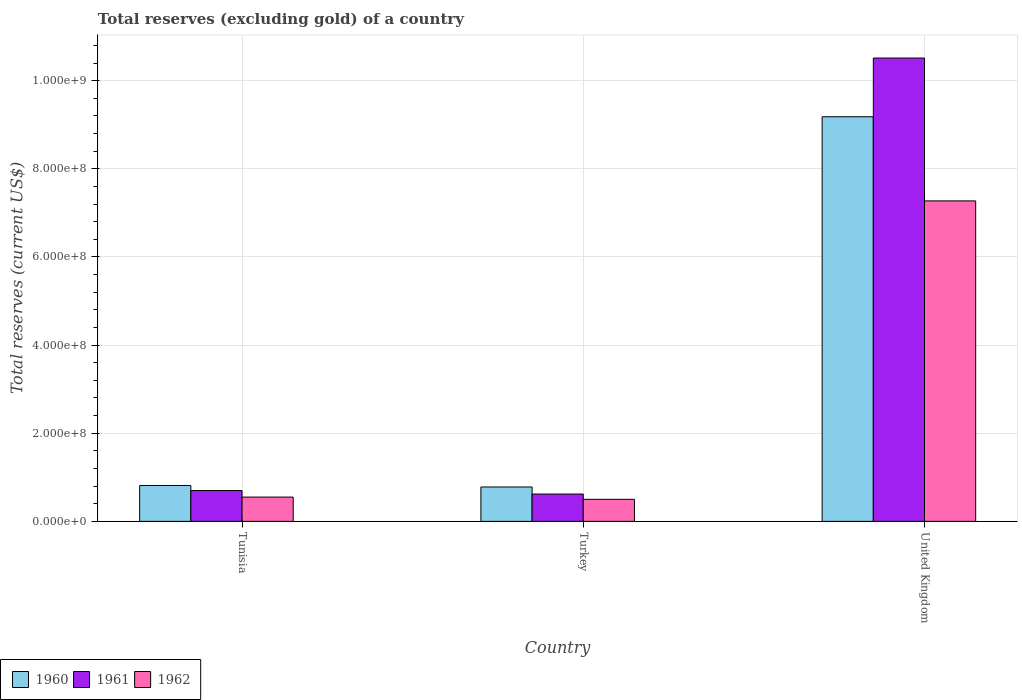How many different coloured bars are there?
Provide a short and direct response. 3. How many groups of bars are there?
Provide a short and direct response. 3. Are the number of bars on each tick of the X-axis equal?
Offer a terse response. Yes. What is the label of the 2nd group of bars from the left?
Provide a short and direct response. Turkey. What is the total reserves (excluding gold) in 1960 in Turkey?
Keep it short and to the point. 7.80e+07. Across all countries, what is the maximum total reserves (excluding gold) in 1962?
Provide a succinct answer. 7.27e+08. Across all countries, what is the minimum total reserves (excluding gold) in 1960?
Provide a short and direct response. 7.80e+07. In which country was the total reserves (excluding gold) in 1960 maximum?
Provide a short and direct response. United Kingdom. In which country was the total reserves (excluding gold) in 1961 minimum?
Your answer should be compact. Turkey. What is the total total reserves (excluding gold) in 1961 in the graph?
Offer a terse response. 1.18e+09. What is the difference between the total reserves (excluding gold) in 1962 in Tunisia and that in Turkey?
Offer a terse response. 5.10e+06. What is the difference between the total reserves (excluding gold) in 1962 in Tunisia and the total reserves (excluding gold) in 1961 in Turkey?
Your response must be concise. -6.90e+06. What is the average total reserves (excluding gold) in 1962 per country?
Give a very brief answer. 2.77e+08. What is the difference between the total reserves (excluding gold) of/in 1962 and total reserves (excluding gold) of/in 1960 in Tunisia?
Your answer should be compact. -2.63e+07. What is the ratio of the total reserves (excluding gold) in 1960 in Turkey to that in United Kingdom?
Keep it short and to the point. 0.08. Is the total reserves (excluding gold) in 1962 in Tunisia less than that in Turkey?
Your response must be concise. No. What is the difference between the highest and the second highest total reserves (excluding gold) in 1960?
Provide a succinct answer. 8.40e+08. What is the difference between the highest and the lowest total reserves (excluding gold) in 1960?
Your answer should be very brief. 8.40e+08. Is the sum of the total reserves (excluding gold) in 1960 in Tunisia and Turkey greater than the maximum total reserves (excluding gold) in 1961 across all countries?
Your response must be concise. No. What does the 3rd bar from the right in United Kingdom represents?
Provide a short and direct response. 1960. Is it the case that in every country, the sum of the total reserves (excluding gold) in 1960 and total reserves (excluding gold) in 1961 is greater than the total reserves (excluding gold) in 1962?
Ensure brevity in your answer.  Yes. Are all the bars in the graph horizontal?
Ensure brevity in your answer.  No. How many countries are there in the graph?
Your response must be concise. 3. Does the graph contain any zero values?
Keep it short and to the point. No. How are the legend labels stacked?
Ensure brevity in your answer.  Horizontal. What is the title of the graph?
Offer a terse response. Total reserves (excluding gold) of a country. What is the label or title of the Y-axis?
Offer a terse response. Total reserves (current US$). What is the Total reserves (current US$) of 1960 in Tunisia?
Your answer should be compact. 8.14e+07. What is the Total reserves (current US$) in 1961 in Tunisia?
Your answer should be compact. 6.99e+07. What is the Total reserves (current US$) of 1962 in Tunisia?
Provide a succinct answer. 5.51e+07. What is the Total reserves (current US$) of 1960 in Turkey?
Your answer should be compact. 7.80e+07. What is the Total reserves (current US$) in 1961 in Turkey?
Offer a terse response. 6.20e+07. What is the Total reserves (current US$) of 1960 in United Kingdom?
Keep it short and to the point. 9.18e+08. What is the Total reserves (current US$) in 1961 in United Kingdom?
Provide a short and direct response. 1.05e+09. What is the Total reserves (current US$) of 1962 in United Kingdom?
Your answer should be compact. 7.27e+08. Across all countries, what is the maximum Total reserves (current US$) in 1960?
Provide a succinct answer. 9.18e+08. Across all countries, what is the maximum Total reserves (current US$) in 1961?
Provide a short and direct response. 1.05e+09. Across all countries, what is the maximum Total reserves (current US$) of 1962?
Keep it short and to the point. 7.27e+08. Across all countries, what is the minimum Total reserves (current US$) of 1960?
Keep it short and to the point. 7.80e+07. Across all countries, what is the minimum Total reserves (current US$) in 1961?
Give a very brief answer. 6.20e+07. Across all countries, what is the minimum Total reserves (current US$) of 1962?
Make the answer very short. 5.00e+07. What is the total Total reserves (current US$) of 1960 in the graph?
Give a very brief answer. 1.08e+09. What is the total Total reserves (current US$) in 1961 in the graph?
Offer a terse response. 1.18e+09. What is the total Total reserves (current US$) in 1962 in the graph?
Your answer should be very brief. 8.32e+08. What is the difference between the Total reserves (current US$) in 1960 in Tunisia and that in Turkey?
Provide a succinct answer. 3.40e+06. What is the difference between the Total reserves (current US$) in 1961 in Tunisia and that in Turkey?
Your answer should be very brief. 7.90e+06. What is the difference between the Total reserves (current US$) in 1962 in Tunisia and that in Turkey?
Provide a short and direct response. 5.10e+06. What is the difference between the Total reserves (current US$) in 1960 in Tunisia and that in United Kingdom?
Offer a very short reply. -8.37e+08. What is the difference between the Total reserves (current US$) in 1961 in Tunisia and that in United Kingdom?
Provide a short and direct response. -9.81e+08. What is the difference between the Total reserves (current US$) in 1962 in Tunisia and that in United Kingdom?
Your answer should be very brief. -6.72e+08. What is the difference between the Total reserves (current US$) in 1960 in Turkey and that in United Kingdom?
Provide a short and direct response. -8.40e+08. What is the difference between the Total reserves (current US$) of 1961 in Turkey and that in United Kingdom?
Your response must be concise. -9.89e+08. What is the difference between the Total reserves (current US$) in 1962 in Turkey and that in United Kingdom?
Give a very brief answer. -6.77e+08. What is the difference between the Total reserves (current US$) in 1960 in Tunisia and the Total reserves (current US$) in 1961 in Turkey?
Your answer should be very brief. 1.94e+07. What is the difference between the Total reserves (current US$) of 1960 in Tunisia and the Total reserves (current US$) of 1962 in Turkey?
Make the answer very short. 3.14e+07. What is the difference between the Total reserves (current US$) of 1961 in Tunisia and the Total reserves (current US$) of 1962 in Turkey?
Provide a succinct answer. 1.99e+07. What is the difference between the Total reserves (current US$) in 1960 in Tunisia and the Total reserves (current US$) in 1961 in United Kingdom?
Give a very brief answer. -9.70e+08. What is the difference between the Total reserves (current US$) of 1960 in Tunisia and the Total reserves (current US$) of 1962 in United Kingdom?
Your answer should be very brief. -6.46e+08. What is the difference between the Total reserves (current US$) in 1961 in Tunisia and the Total reserves (current US$) in 1962 in United Kingdom?
Your response must be concise. -6.57e+08. What is the difference between the Total reserves (current US$) in 1960 in Turkey and the Total reserves (current US$) in 1961 in United Kingdom?
Your answer should be compact. -9.73e+08. What is the difference between the Total reserves (current US$) in 1960 in Turkey and the Total reserves (current US$) in 1962 in United Kingdom?
Your answer should be compact. -6.49e+08. What is the difference between the Total reserves (current US$) of 1961 in Turkey and the Total reserves (current US$) of 1962 in United Kingdom?
Your answer should be compact. -6.65e+08. What is the average Total reserves (current US$) in 1960 per country?
Your answer should be very brief. 3.59e+08. What is the average Total reserves (current US$) in 1961 per country?
Your response must be concise. 3.94e+08. What is the average Total reserves (current US$) in 1962 per country?
Provide a short and direct response. 2.77e+08. What is the difference between the Total reserves (current US$) of 1960 and Total reserves (current US$) of 1961 in Tunisia?
Keep it short and to the point. 1.15e+07. What is the difference between the Total reserves (current US$) of 1960 and Total reserves (current US$) of 1962 in Tunisia?
Your answer should be compact. 2.63e+07. What is the difference between the Total reserves (current US$) of 1961 and Total reserves (current US$) of 1962 in Tunisia?
Offer a terse response. 1.48e+07. What is the difference between the Total reserves (current US$) of 1960 and Total reserves (current US$) of 1961 in Turkey?
Offer a terse response. 1.60e+07. What is the difference between the Total reserves (current US$) of 1960 and Total reserves (current US$) of 1962 in Turkey?
Keep it short and to the point. 2.80e+07. What is the difference between the Total reserves (current US$) of 1960 and Total reserves (current US$) of 1961 in United Kingdom?
Keep it short and to the point. -1.33e+08. What is the difference between the Total reserves (current US$) of 1960 and Total reserves (current US$) of 1962 in United Kingdom?
Make the answer very short. 1.91e+08. What is the difference between the Total reserves (current US$) of 1961 and Total reserves (current US$) of 1962 in United Kingdom?
Your response must be concise. 3.24e+08. What is the ratio of the Total reserves (current US$) in 1960 in Tunisia to that in Turkey?
Ensure brevity in your answer.  1.04. What is the ratio of the Total reserves (current US$) in 1961 in Tunisia to that in Turkey?
Your response must be concise. 1.13. What is the ratio of the Total reserves (current US$) of 1962 in Tunisia to that in Turkey?
Provide a short and direct response. 1.1. What is the ratio of the Total reserves (current US$) of 1960 in Tunisia to that in United Kingdom?
Provide a succinct answer. 0.09. What is the ratio of the Total reserves (current US$) of 1961 in Tunisia to that in United Kingdom?
Your response must be concise. 0.07. What is the ratio of the Total reserves (current US$) of 1962 in Tunisia to that in United Kingdom?
Provide a short and direct response. 0.08. What is the ratio of the Total reserves (current US$) of 1960 in Turkey to that in United Kingdom?
Your answer should be very brief. 0.09. What is the ratio of the Total reserves (current US$) in 1961 in Turkey to that in United Kingdom?
Provide a short and direct response. 0.06. What is the ratio of the Total reserves (current US$) in 1962 in Turkey to that in United Kingdom?
Make the answer very short. 0.07. What is the difference between the highest and the second highest Total reserves (current US$) in 1960?
Your answer should be very brief. 8.37e+08. What is the difference between the highest and the second highest Total reserves (current US$) in 1961?
Ensure brevity in your answer.  9.81e+08. What is the difference between the highest and the second highest Total reserves (current US$) in 1962?
Offer a very short reply. 6.72e+08. What is the difference between the highest and the lowest Total reserves (current US$) in 1960?
Keep it short and to the point. 8.40e+08. What is the difference between the highest and the lowest Total reserves (current US$) in 1961?
Ensure brevity in your answer.  9.89e+08. What is the difference between the highest and the lowest Total reserves (current US$) in 1962?
Ensure brevity in your answer.  6.77e+08. 